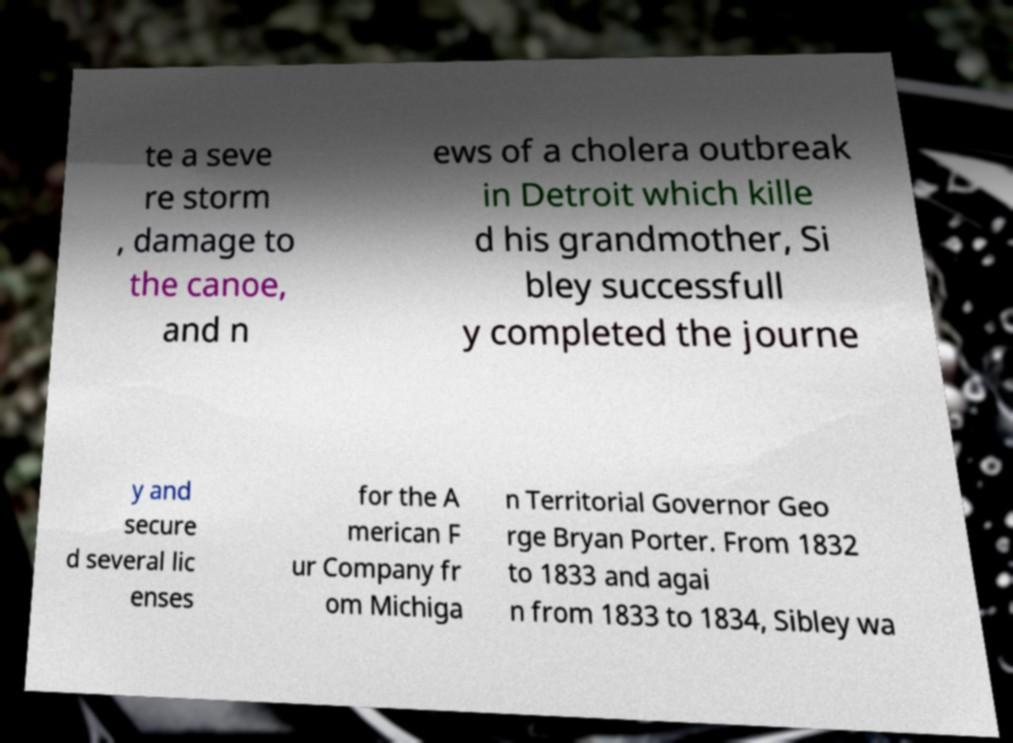Can you accurately transcribe the text from the provided image for me? te a seve re storm , damage to the canoe, and n ews of a cholera outbreak in Detroit which kille d his grandmother, Si bley successfull y completed the journe y and secure d several lic enses for the A merican F ur Company fr om Michiga n Territorial Governor Geo rge Bryan Porter. From 1832 to 1833 and agai n from 1833 to 1834, Sibley wa 